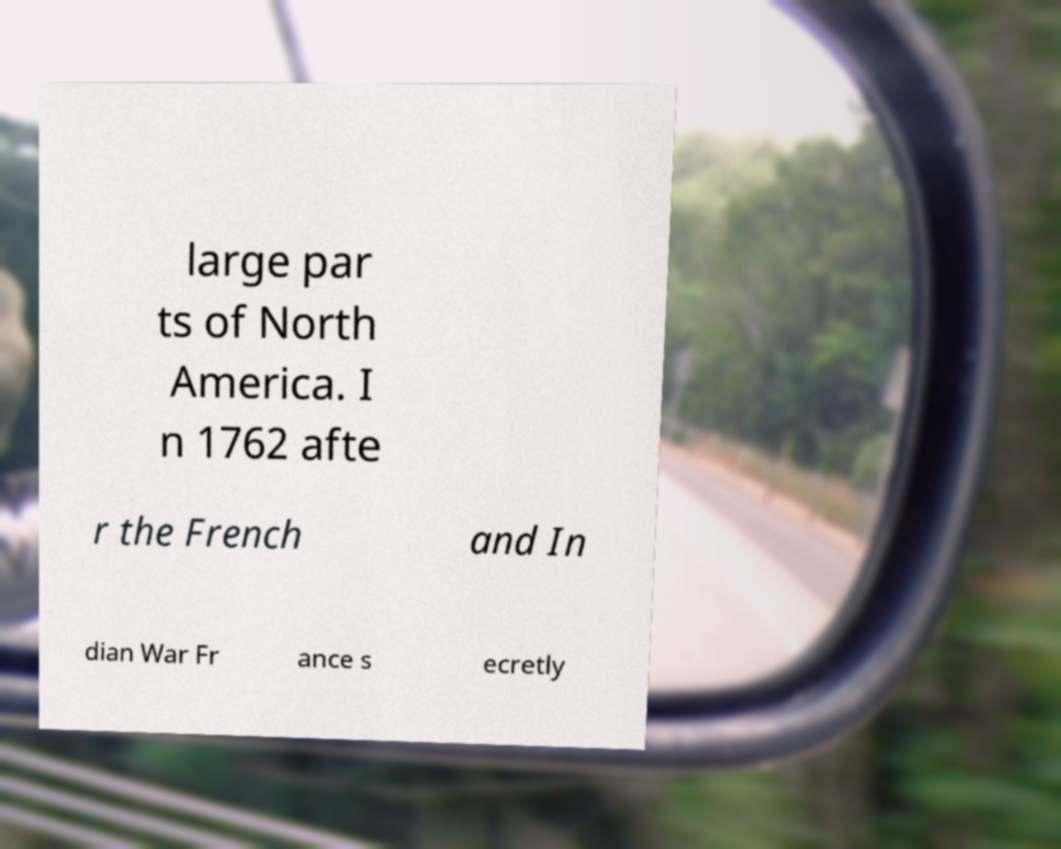For documentation purposes, I need the text within this image transcribed. Could you provide that? large par ts of North America. I n 1762 afte r the French and In dian War Fr ance s ecretly 